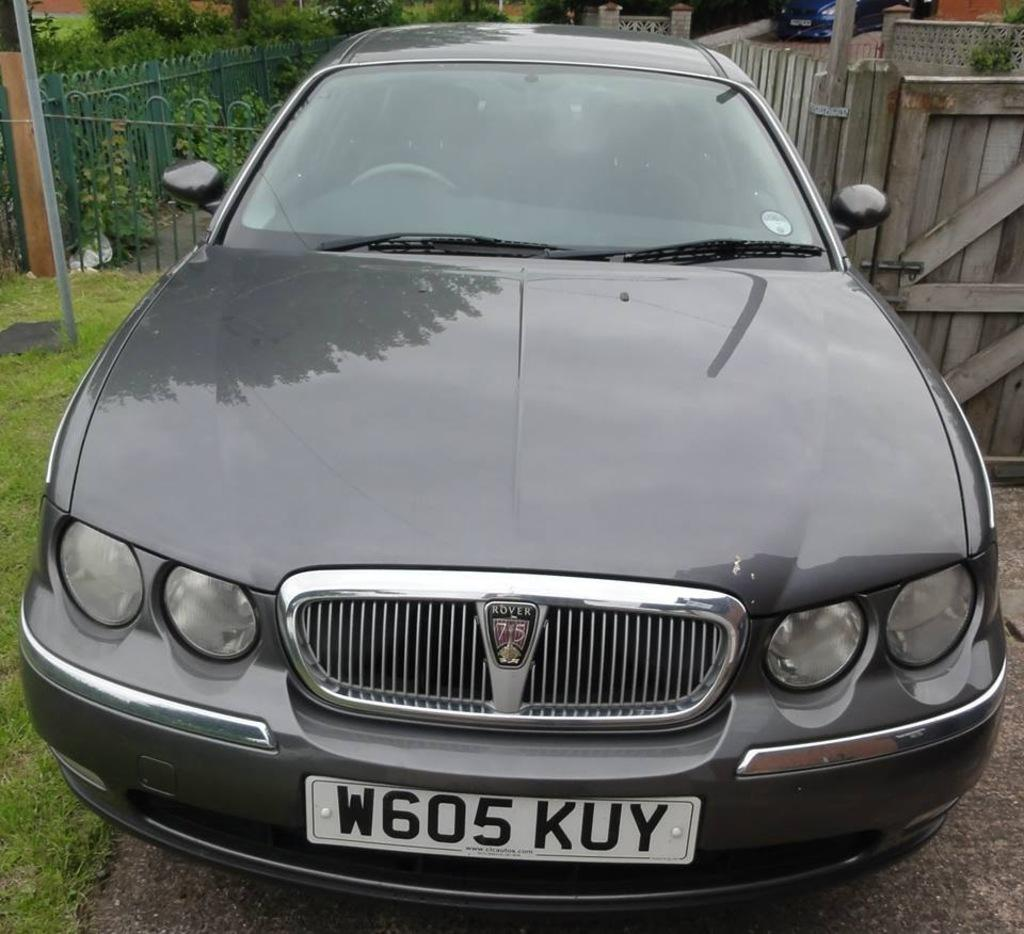Provide a one-sentence caption for the provided image. Car with the tag on the front of it that is W605 KUY. 